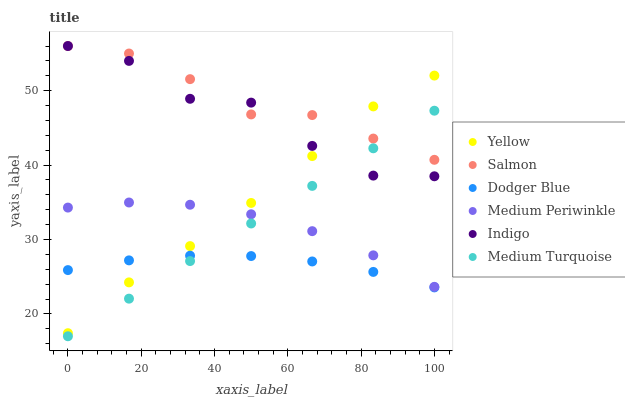Does Dodger Blue have the minimum area under the curve?
Answer yes or no. Yes. Does Salmon have the maximum area under the curve?
Answer yes or no. Yes. Does Medium Periwinkle have the minimum area under the curve?
Answer yes or no. No. Does Medium Periwinkle have the maximum area under the curve?
Answer yes or no. No. Is Medium Turquoise the smoothest?
Answer yes or no. Yes. Is Indigo the roughest?
Answer yes or no. Yes. Is Medium Periwinkle the smoothest?
Answer yes or no. No. Is Medium Periwinkle the roughest?
Answer yes or no. No. Does Medium Turquoise have the lowest value?
Answer yes or no. Yes. Does Medium Periwinkle have the lowest value?
Answer yes or no. No. Does Salmon have the highest value?
Answer yes or no. Yes. Does Medium Periwinkle have the highest value?
Answer yes or no. No. Is Medium Periwinkle less than Indigo?
Answer yes or no. Yes. Is Indigo greater than Dodger Blue?
Answer yes or no. Yes. Does Yellow intersect Medium Periwinkle?
Answer yes or no. Yes. Is Yellow less than Medium Periwinkle?
Answer yes or no. No. Is Yellow greater than Medium Periwinkle?
Answer yes or no. No. Does Medium Periwinkle intersect Indigo?
Answer yes or no. No. 